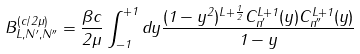<formula> <loc_0><loc_0><loc_500><loc_500>B ^ { ( c / 2 \mu ) } _ { L , N ^ { \prime } , N ^ { \prime \prime } } = \frac { \beta c } { 2 \mu } \int ^ { + 1 } _ { - 1 } d y \frac { ( 1 - y ^ { 2 } ) ^ { L + \frac { 1 } { 2 } } C ^ { L + 1 } _ { n ^ { \prime } } ( y ) C ^ { L + 1 } _ { n ^ { \prime \prime } } ( y ) } { 1 - y }</formula> 